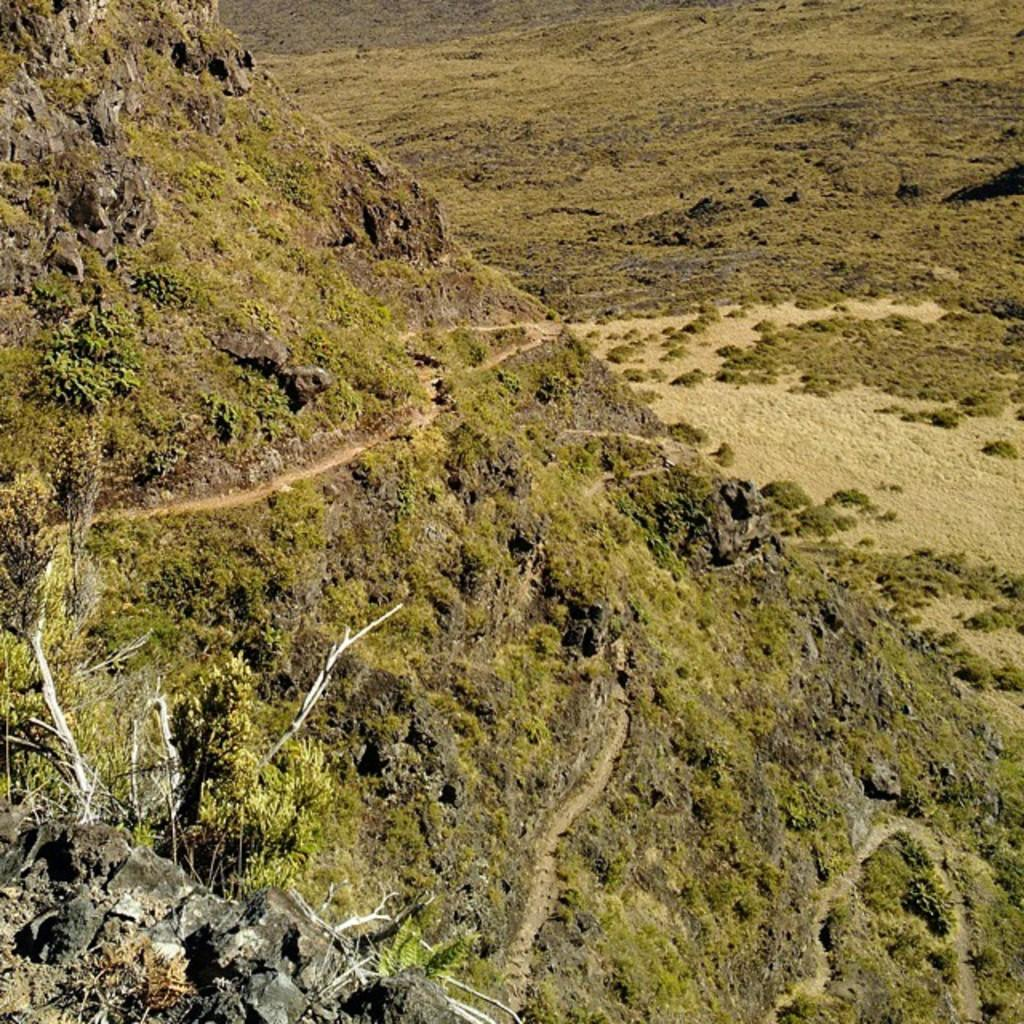What type of vegetation is present at the bottom of the image? There are trees at the bottom of the image. What type of landscape feature can be seen in the background of the image? There are hills visible in the background of the image. What type of health advice can be seen on the trees in the image? There is no health advice present on the trees in the image; it only features trees and hills. What type of lettuce is growing on the hills in the image? There is no lettuce present in the image; it only features trees and hills. 